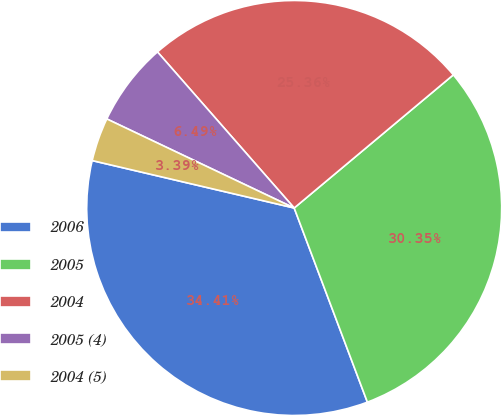<chart> <loc_0><loc_0><loc_500><loc_500><pie_chart><fcel>2006<fcel>2005<fcel>2004<fcel>2005 (4)<fcel>2004 (5)<nl><fcel>34.41%<fcel>30.35%<fcel>25.36%<fcel>6.49%<fcel>3.39%<nl></chart> 